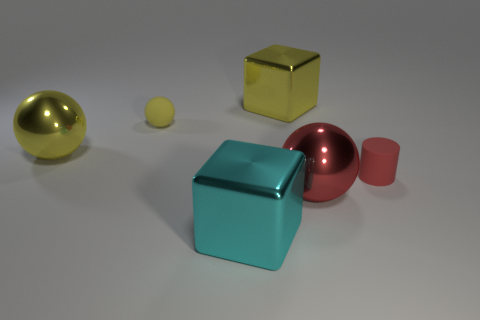Subtract all red spheres. How many spheres are left? 2 Add 2 green shiny cubes. How many objects exist? 8 Subtract all red spheres. How many spheres are left? 2 Subtract 2 yellow balls. How many objects are left? 4 Subtract all cylinders. How many objects are left? 5 Subtract 2 spheres. How many spheres are left? 1 Subtract all red cubes. Subtract all blue cylinders. How many cubes are left? 2 Subtract all yellow cubes. How many gray balls are left? 0 Subtract all small red rubber cylinders. Subtract all large spheres. How many objects are left? 3 Add 5 tiny red matte cylinders. How many tiny red matte cylinders are left? 6 